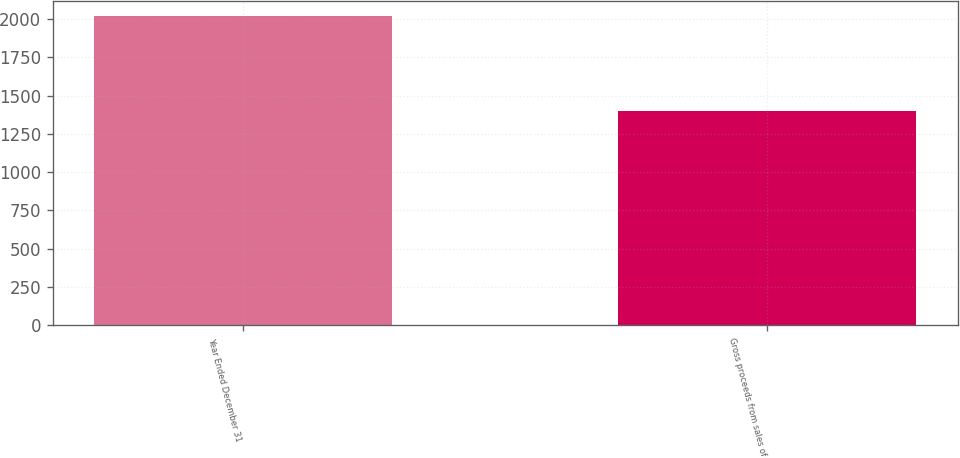<chart> <loc_0><loc_0><loc_500><loc_500><bar_chart><fcel>Year Ended December 31<fcel>Gross proceeds from sales of<nl><fcel>2017<fcel>1398<nl></chart> 